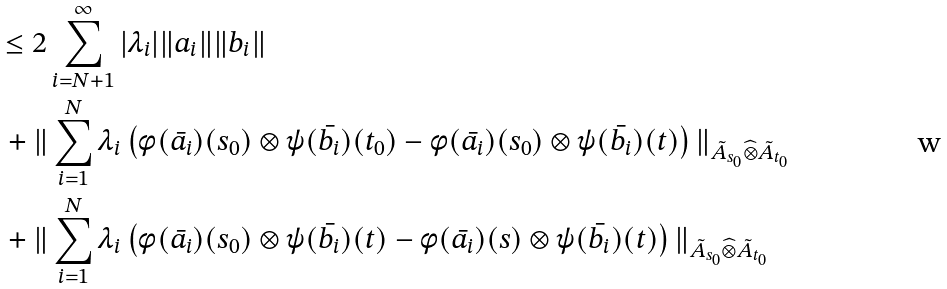<formula> <loc_0><loc_0><loc_500><loc_500>\quad & \leq 2 \sum _ { i = N + 1 } ^ { \infty } | \lambda _ { i } | \| a _ { i } \| \| b _ { i } \| \\ & \, + \| \sum _ { i = 1 } ^ { N } \lambda _ { i } \left ( \phi ( \bar { a _ { i } } ) ( s _ { 0 } ) \otimes \psi ( \bar { b _ { i } } ) ( t _ { 0 } ) - \phi ( \bar { a _ { i } } ) ( s _ { 0 } ) \otimes \psi ( \bar { b _ { i } } ) ( t ) \right ) \| _ { \tilde { A } _ { s _ { 0 } } \widehat { \otimes } \tilde { A } _ { t _ { 0 } } } \\ & \, + \| \sum _ { i = 1 } ^ { N } \lambda _ { i } \left ( \phi ( \bar { a _ { i } } ) ( s _ { 0 } ) \otimes \psi ( \bar { b _ { i } } ) ( t ) - \phi ( \bar { a _ { i } } ) ( s ) \otimes \psi ( \bar { b _ { i } } ) ( t ) \right ) \| _ { \tilde { A } _ { s _ { 0 } } \widehat { \otimes } \tilde { A } _ { t _ { 0 } } }</formula> 